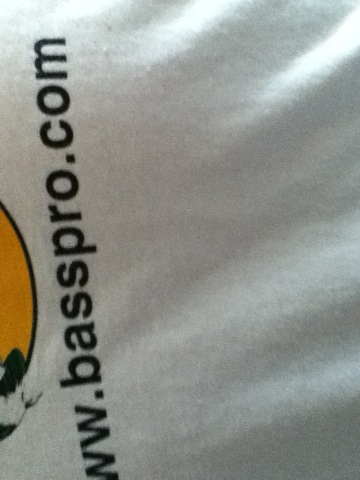What kind of products does the company represented on this shirt sell? Bass Pro Shops specializes in selling outdoor recreation gear, particularly for fishing, hunting, camping, and similar activities. They offer a wide range of equipment, clothing, and accessories for outdoor enthusiasts. 